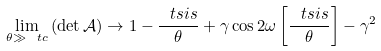Convert formula to latex. <formula><loc_0><loc_0><loc_500><loc_500>\lim _ { \theta \gg \ t c } \left ( \det \mathcal { A } \right ) \rightarrow 1 - \frac { \ t s i s } { \theta } + \gamma \cos 2 \omega \left [ \frac { \ t s i s } { \theta } \right ] - \gamma ^ { 2 }</formula> 